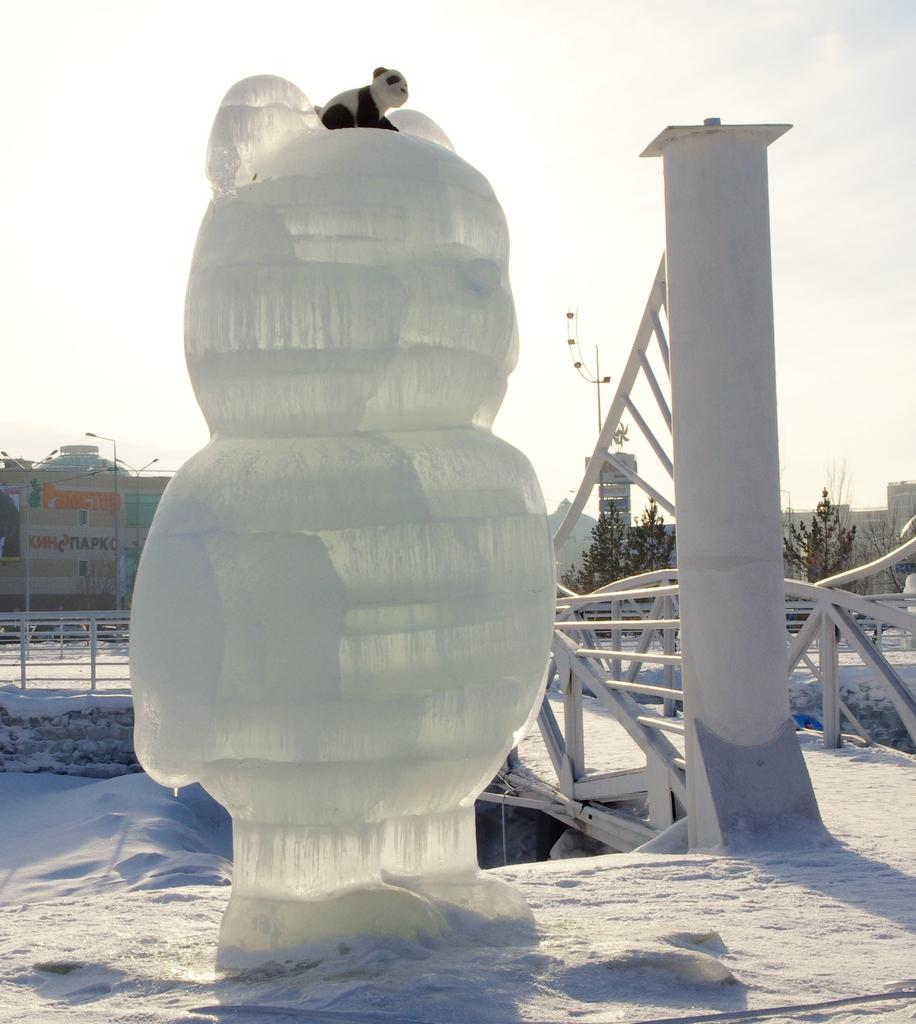What is the main subject in the image? There is a statue in the image. What other architectural elements can be seen in the image? There is a pillar and railing in the image. What type of living creature is present in the image? There is an animal in the image. What can be seen in the background of the image? There are buildings, trees, and the sky visible in the background of the image. What degree does the minister hold in the image? There is no minister or degree mentioned in the image; it features a statue, pillar, railing, an animal, and a background with buildings, trees, and the sky. 